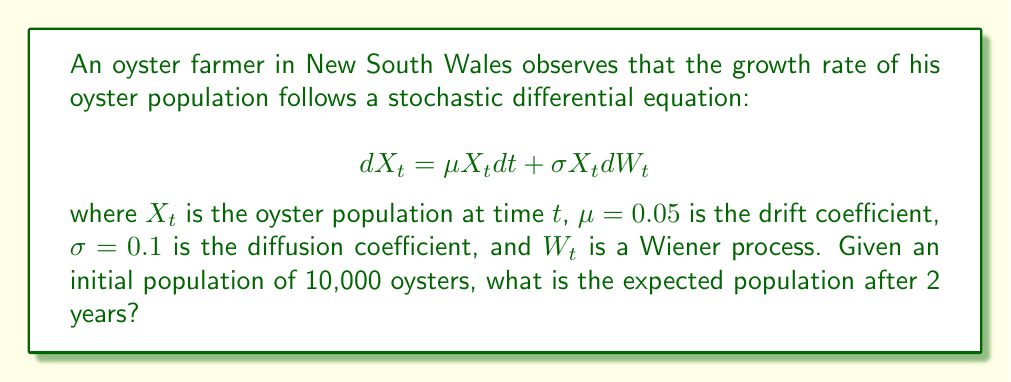Teach me how to tackle this problem. To solve this problem, we'll follow these steps:

1) The stochastic differential equation given is a geometric Brownian motion model.

2) For geometric Brownian motion, the expected value of $X_t$ is given by:

   $$E[X_t] = X_0 e^{\mu t}$$

   where $X_0$ is the initial population, $\mu$ is the drift coefficient, and $t$ is the time.

3) We're given:
   - $X_0 = 10,000$ (initial population)
   - $\mu = 0.05$ (drift coefficient)
   - $t = 2$ years

4) Let's substitute these values into the formula:

   $$E[X_2] = 10,000 e^{0.05 \cdot 2}$$

5) Calculate:
   $$E[X_2] = 10,000 e^{0.1}$$
   $$E[X_2] = 10,000 \cdot 1.10517$$
   $$E[X_2] = 11,051.7$$

6) Rounding to the nearest whole oyster (as we can't have fractional oysters):

   $$E[X_2] \approx 11,052$$

Therefore, the expected oyster population after 2 years is approximately 11,052.
Answer: 11,052 oysters 